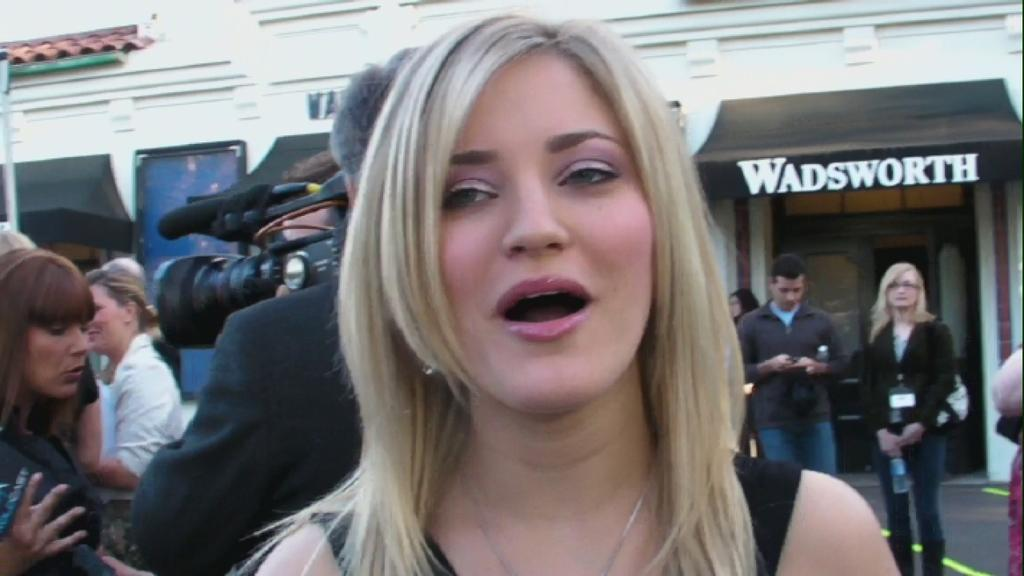What is the main subject of the image? There is a woman standing in the image. Are there any other people in the image? Yes, there are people standing behind the woman. What are the people holding in their hands? The people are holding something in their hands, but the facts do not specify what it is. What can be seen in the background of the image? There is a building in the background of the image. What type of lock can be seen on the crook's arm in the image? There is no crook or lock present in the image. 